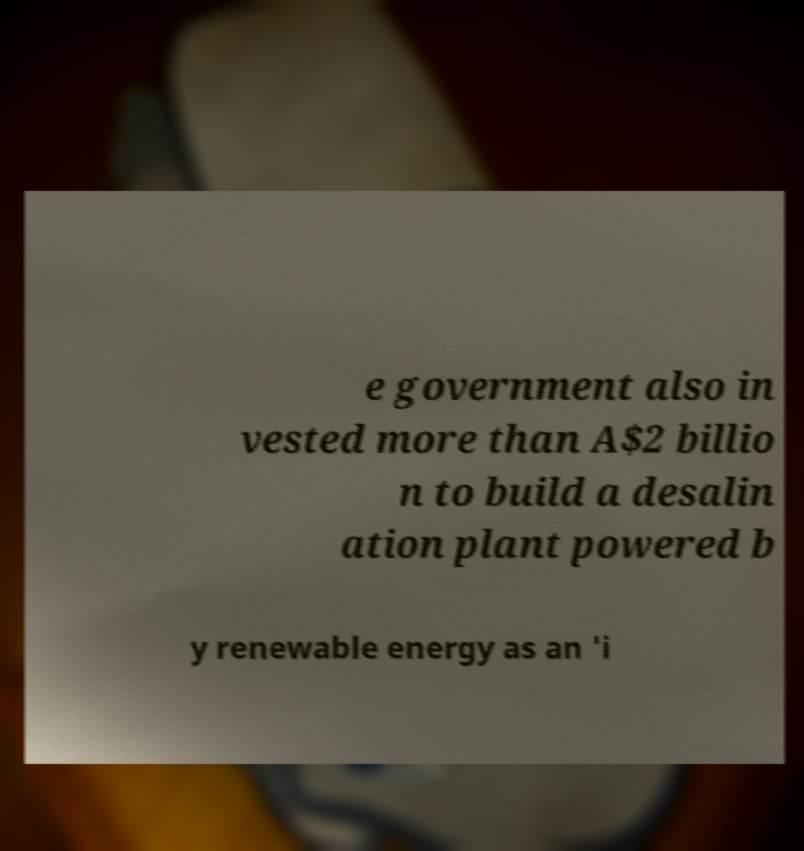Please identify and transcribe the text found in this image. e government also in vested more than A$2 billio n to build a desalin ation plant powered b y renewable energy as an 'i 